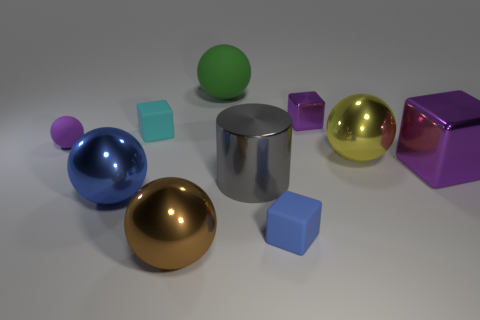What color is the cube that is both on the left side of the big purple metal object and in front of the yellow sphere?
Keep it short and to the point. Blue. How many blue matte cylinders are the same size as the green ball?
Ensure brevity in your answer.  0. There is a blue object to the right of the large ball that is in front of the large blue object; what is its shape?
Offer a very short reply. Cube. The rubber thing in front of the small purple matte ball that is in front of the shiny block that is behind the small cyan cube is what shape?
Provide a short and direct response. Cube. What number of brown metallic things have the same shape as the big green thing?
Provide a succinct answer. 1. What number of purple objects are on the left side of the blue matte block that is left of the yellow shiny thing?
Give a very brief answer. 1. How many metallic objects are purple spheres or large green balls?
Provide a short and direct response. 0. Is there a tiny blue object that has the same material as the large blue sphere?
Offer a very short reply. No. What number of things are either large shiny balls left of the large yellow thing or tiny objects right of the gray metal thing?
Offer a terse response. 4. There is a small block in front of the yellow object; is it the same color as the large metal cylinder?
Give a very brief answer. No. 